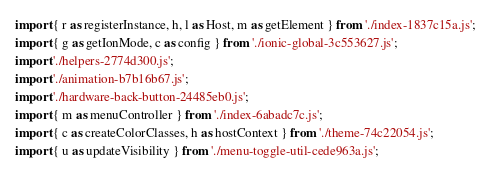<code> <loc_0><loc_0><loc_500><loc_500><_JavaScript_>import { r as registerInstance, h, l as Host, m as getElement } from './index-1837c15a.js';
import { g as getIonMode, c as config } from './ionic-global-3c553627.js';
import './helpers-2774d300.js';
import './animation-b7b16b67.js';
import './hardware-back-button-24485eb0.js';
import { m as menuController } from './index-6abadc7c.js';
import { c as createColorClasses, h as hostContext } from './theme-74c22054.js';
import { u as updateVisibility } from './menu-toggle-util-cede963a.js';
</code> 